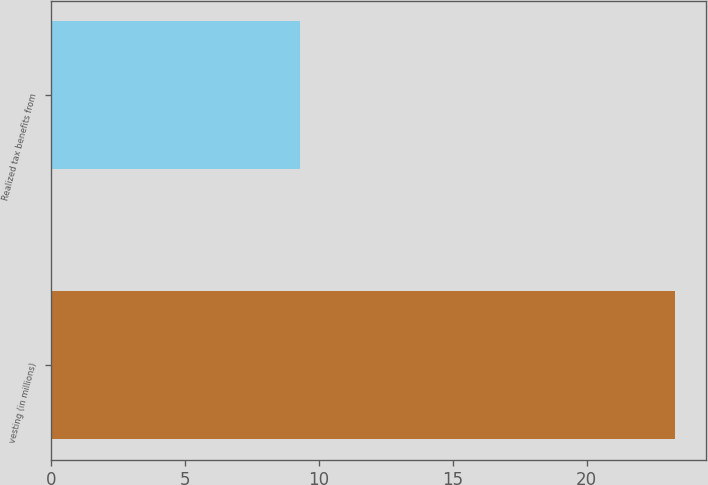Convert chart. <chart><loc_0><loc_0><loc_500><loc_500><bar_chart><fcel>vesting (in millions)<fcel>Realized tax benefits from<nl><fcel>23.3<fcel>9.3<nl></chart> 